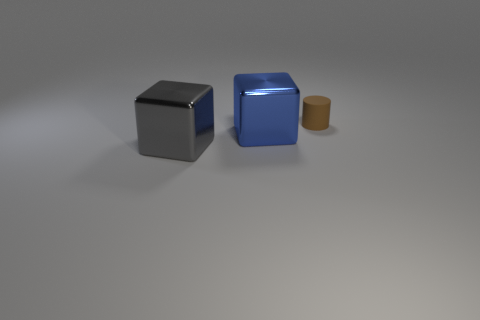Add 1 small matte cylinders. How many objects exist? 4 Subtract all blocks. How many objects are left? 1 Subtract all brown cylinders. Subtract all blue things. How many objects are left? 1 Add 1 large blue things. How many large blue things are left? 2 Add 1 tiny brown matte objects. How many tiny brown matte objects exist? 2 Subtract 0 brown cubes. How many objects are left? 3 